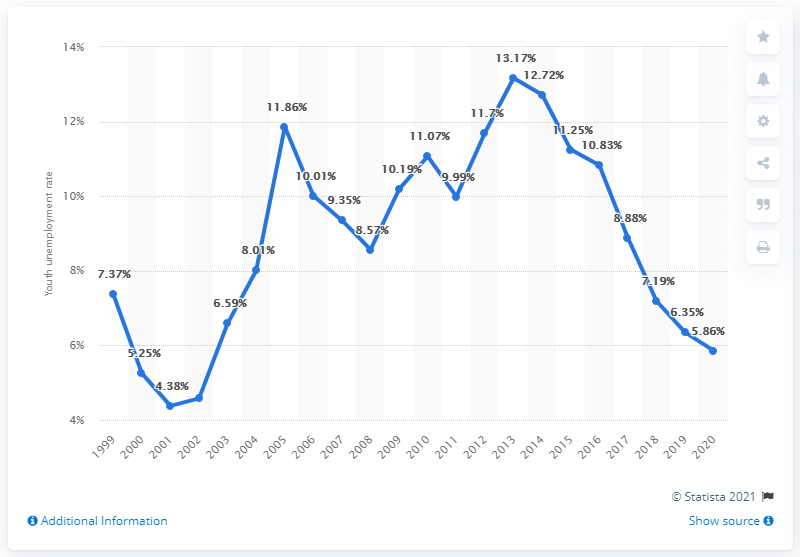Indicate a few pertinent items in this graphic. In 2020, the youth unemployment rate in the Netherlands was 5.86%. 